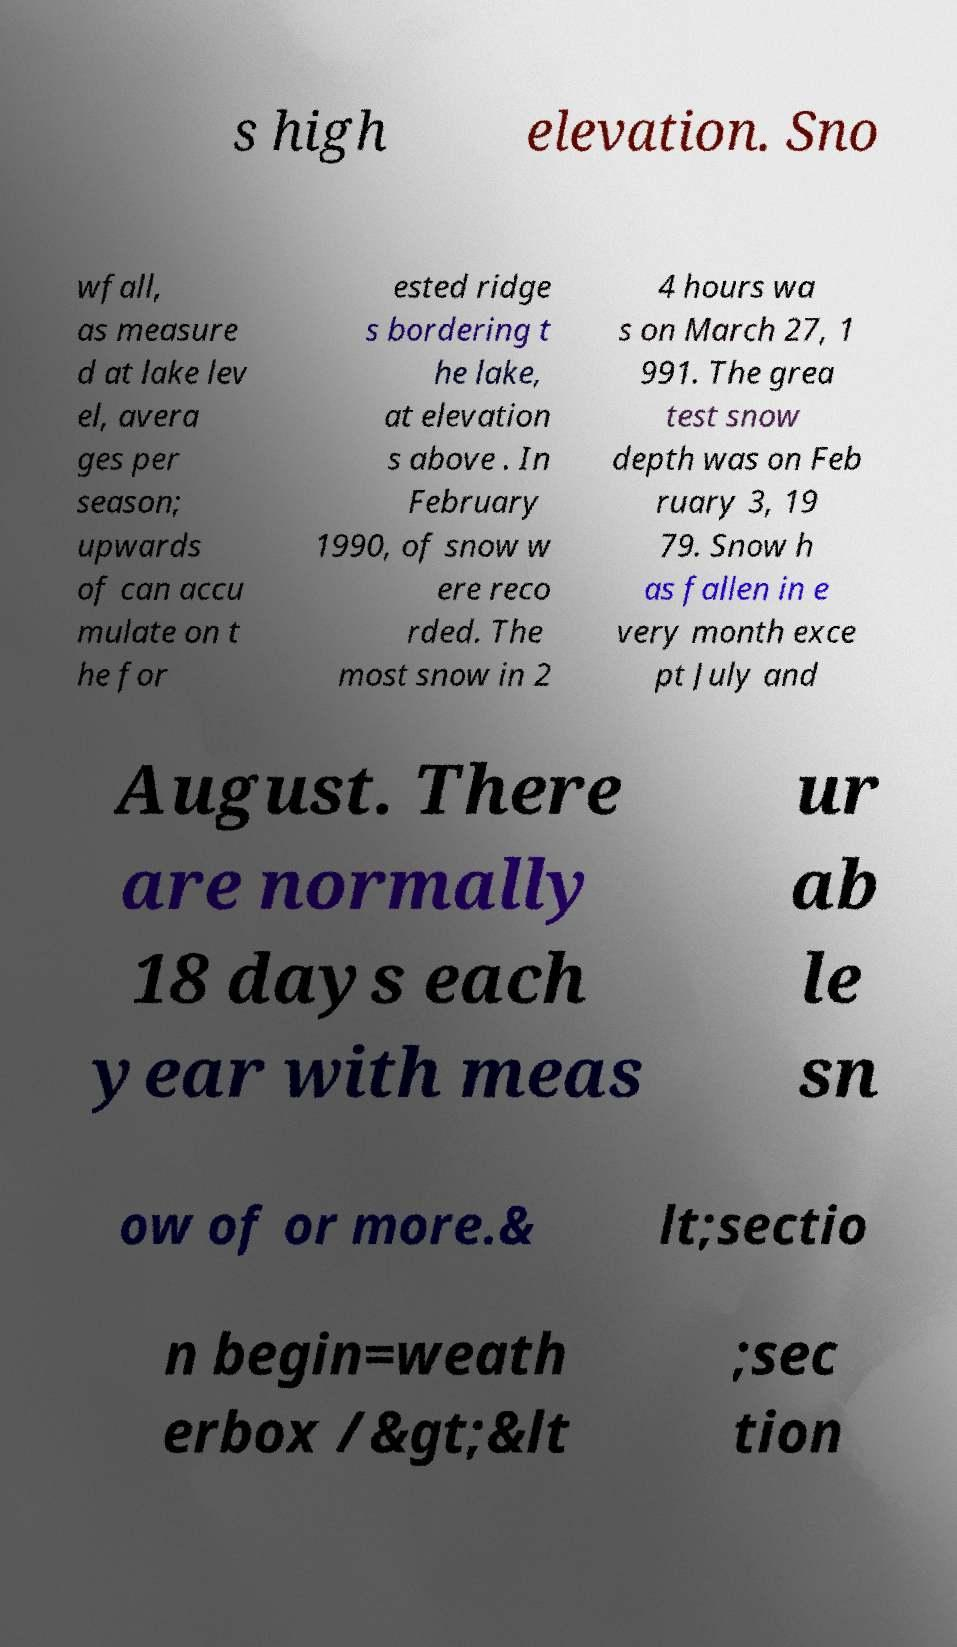Could you extract and type out the text from this image? s high elevation. Sno wfall, as measure d at lake lev el, avera ges per season; upwards of can accu mulate on t he for ested ridge s bordering t he lake, at elevation s above . In February 1990, of snow w ere reco rded. The most snow in 2 4 hours wa s on March 27, 1 991. The grea test snow depth was on Feb ruary 3, 19 79. Snow h as fallen in e very month exce pt July and August. There are normally 18 days each year with meas ur ab le sn ow of or more.& lt;sectio n begin=weath erbox /&gt;&lt ;sec tion 